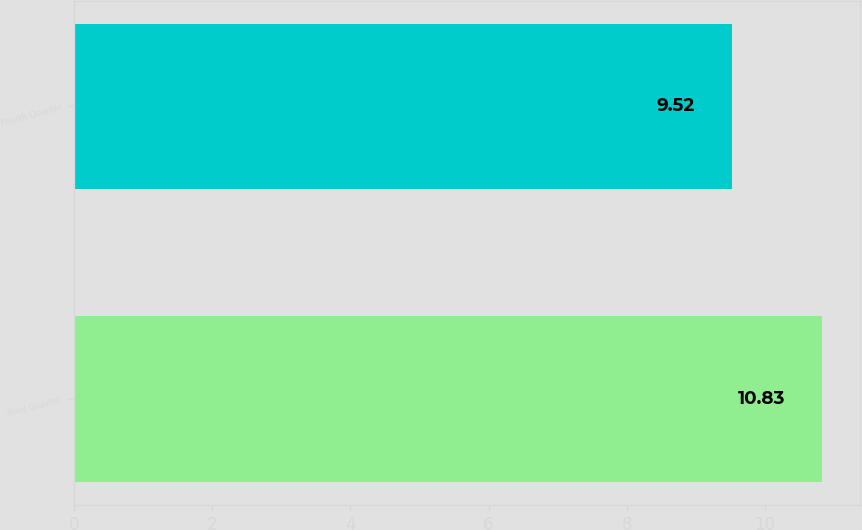Convert chart. <chart><loc_0><loc_0><loc_500><loc_500><bar_chart><fcel>Third Quarter<fcel>Fourth Quarter<nl><fcel>10.83<fcel>9.52<nl></chart> 